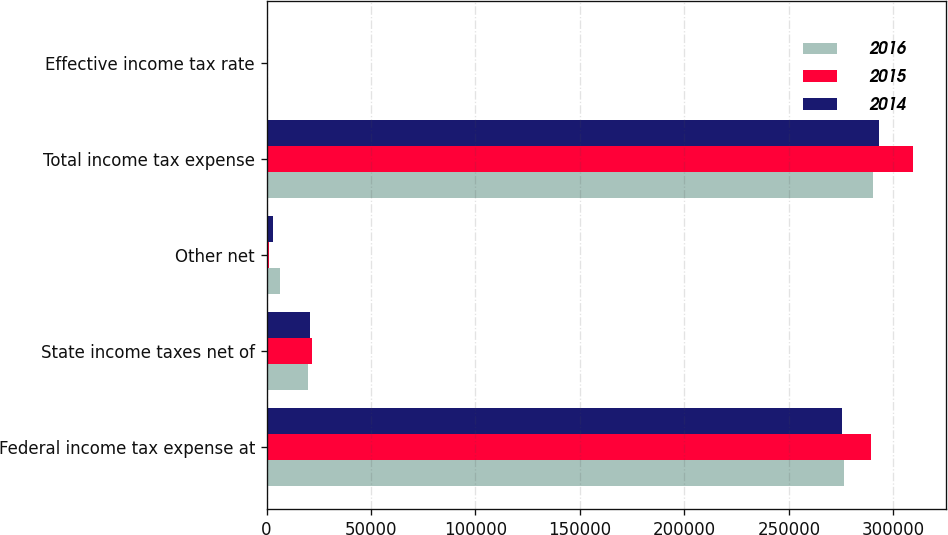Convert chart. <chart><loc_0><loc_0><loc_500><loc_500><stacked_bar_chart><ecel><fcel>Federal income tax expense at<fcel>State income taxes net of<fcel>Other net<fcel>Total income tax expense<fcel>Effective income tax rate<nl><fcel>2016<fcel>276405<fcel>20038<fcel>6192<fcel>290251<fcel>36.8<nl><fcel>2015<fcel>289107<fcel>21613<fcel>1061<fcel>309659<fcel>37.5<nl><fcel>2014<fcel>275602<fcel>20549<fcel>2867<fcel>293284<fcel>37.2<nl></chart> 